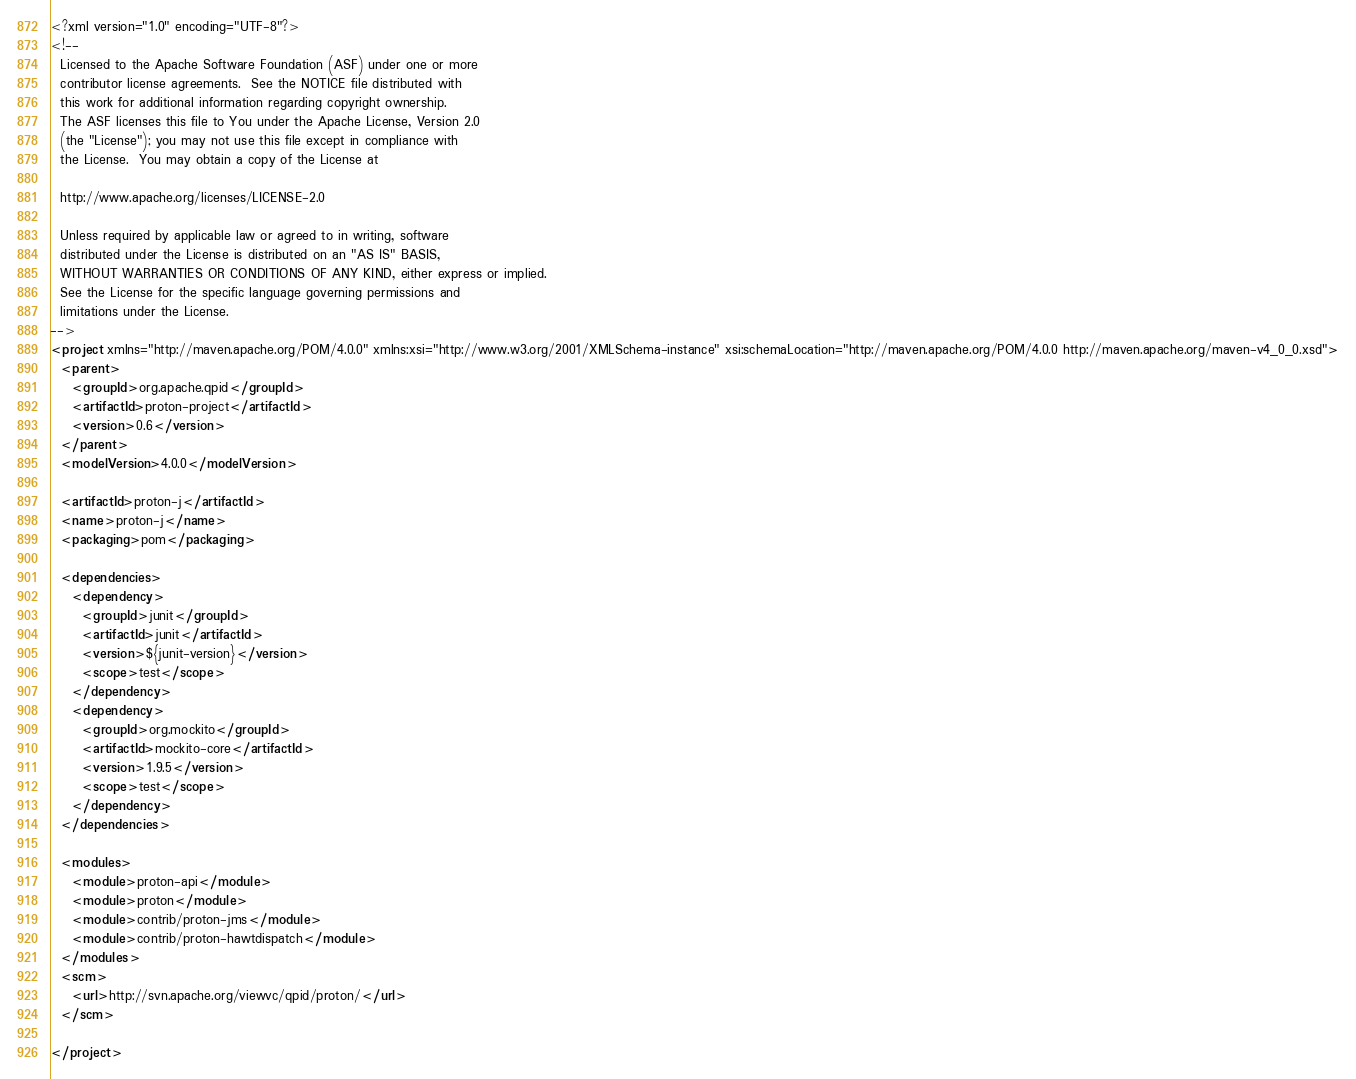<code> <loc_0><loc_0><loc_500><loc_500><_XML_><?xml version="1.0" encoding="UTF-8"?>
<!--
  Licensed to the Apache Software Foundation (ASF) under one or more
  contributor license agreements.  See the NOTICE file distributed with
  this work for additional information regarding copyright ownership.
  The ASF licenses this file to You under the Apache License, Version 2.0
  (the "License"); you may not use this file except in compliance with
  the License.  You may obtain a copy of the License at
  
  http://www.apache.org/licenses/LICENSE-2.0
  
  Unless required by applicable law or agreed to in writing, software
  distributed under the License is distributed on an "AS IS" BASIS,
  WITHOUT WARRANTIES OR CONDITIONS OF ANY KIND, either express or implied.
  See the License for the specific language governing permissions and
  limitations under the License.
-->
<project xmlns="http://maven.apache.org/POM/4.0.0" xmlns:xsi="http://www.w3.org/2001/XMLSchema-instance" xsi:schemaLocation="http://maven.apache.org/POM/4.0.0 http://maven.apache.org/maven-v4_0_0.xsd">
  <parent>
    <groupId>org.apache.qpid</groupId>
    <artifactId>proton-project</artifactId>
    <version>0.6</version>
  </parent>
  <modelVersion>4.0.0</modelVersion>

  <artifactId>proton-j</artifactId>
  <name>proton-j</name>
  <packaging>pom</packaging>

  <dependencies>
    <dependency>
      <groupId>junit</groupId>
      <artifactId>junit</artifactId>
      <version>${junit-version}</version>
      <scope>test</scope>
    </dependency>
    <dependency>
      <groupId>org.mockito</groupId>
      <artifactId>mockito-core</artifactId>
      <version>1.9.5</version>
      <scope>test</scope>
    </dependency>
  </dependencies>

  <modules>
    <module>proton-api</module>
    <module>proton</module>
    <module>contrib/proton-jms</module>
    <module>contrib/proton-hawtdispatch</module>
  </modules>
  <scm>
    <url>http://svn.apache.org/viewvc/qpid/proton/</url>
  </scm>
    
</project>
</code> 